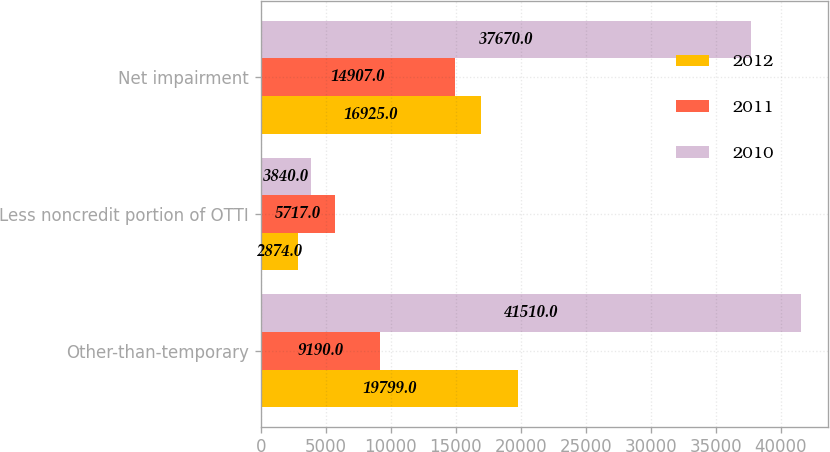Convert chart to OTSL. <chart><loc_0><loc_0><loc_500><loc_500><stacked_bar_chart><ecel><fcel>Other-than-temporary<fcel>Less noncredit portion of OTTI<fcel>Net impairment<nl><fcel>2012<fcel>19799<fcel>2874<fcel>16925<nl><fcel>2011<fcel>9190<fcel>5717<fcel>14907<nl><fcel>2010<fcel>41510<fcel>3840<fcel>37670<nl></chart> 